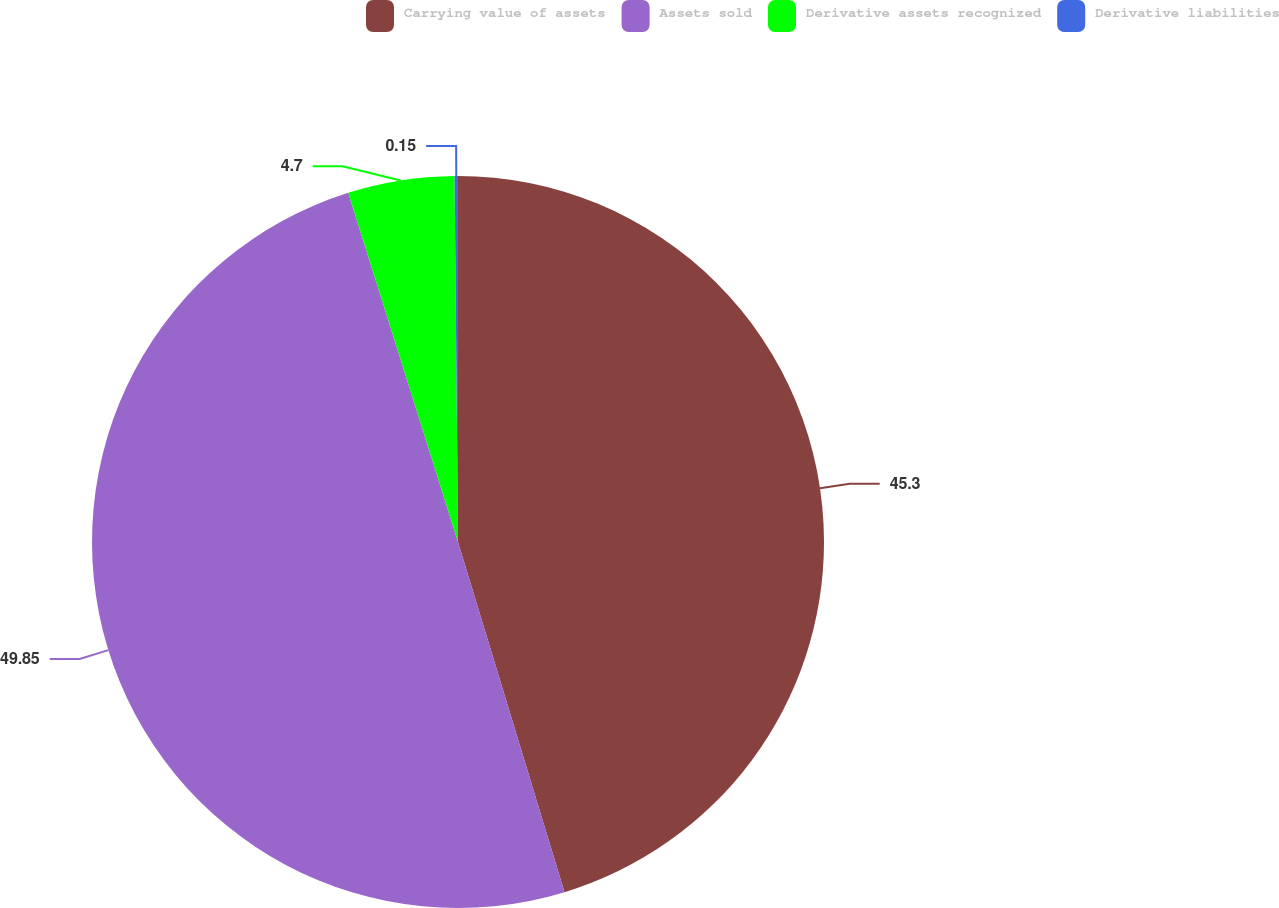Convert chart to OTSL. <chart><loc_0><loc_0><loc_500><loc_500><pie_chart><fcel>Carrying value of assets<fcel>Assets sold<fcel>Derivative assets recognized<fcel>Derivative liabilities<nl><fcel>45.3%<fcel>49.85%<fcel>4.7%<fcel>0.15%<nl></chart> 